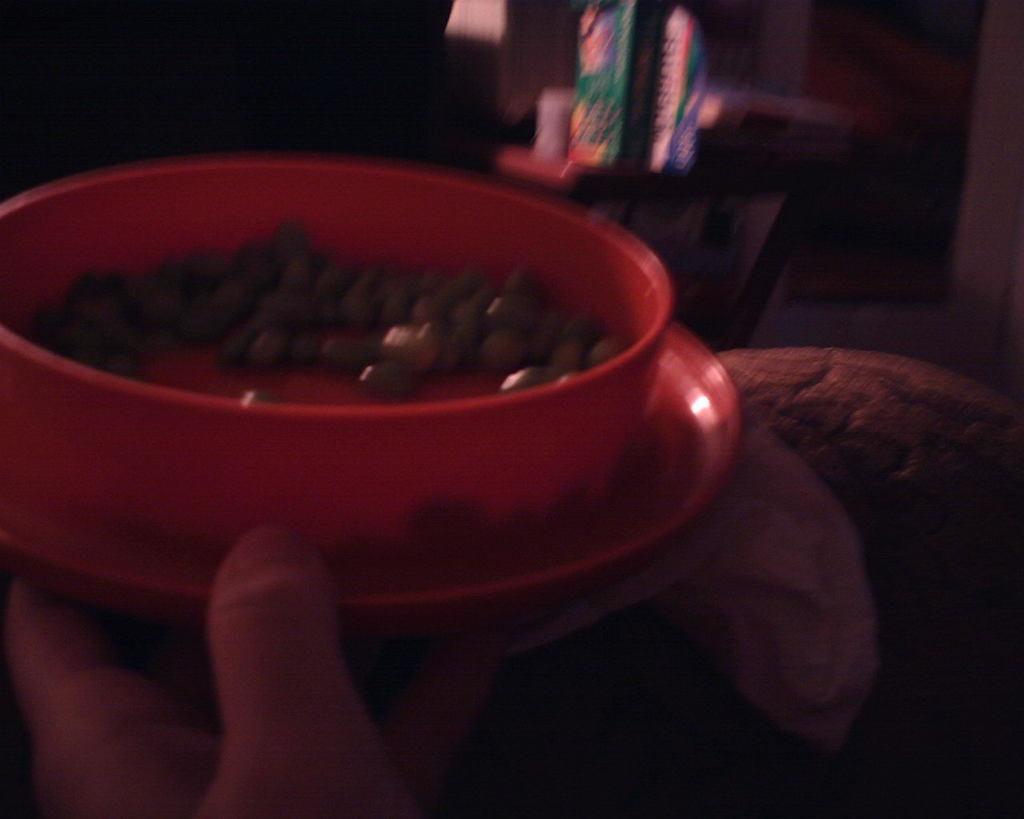What is present on the plate in the image? There is a bowl in the image. What is the relationship between the bowl and the plate? The bowl is on a plate in the image. What is inside the bowl? There is food in the bowl. Who or what is holding the bowl? A human hand is holding the bowl. What type of rice can be seen on the scale in the image? There is no rice or scale present in the image. 